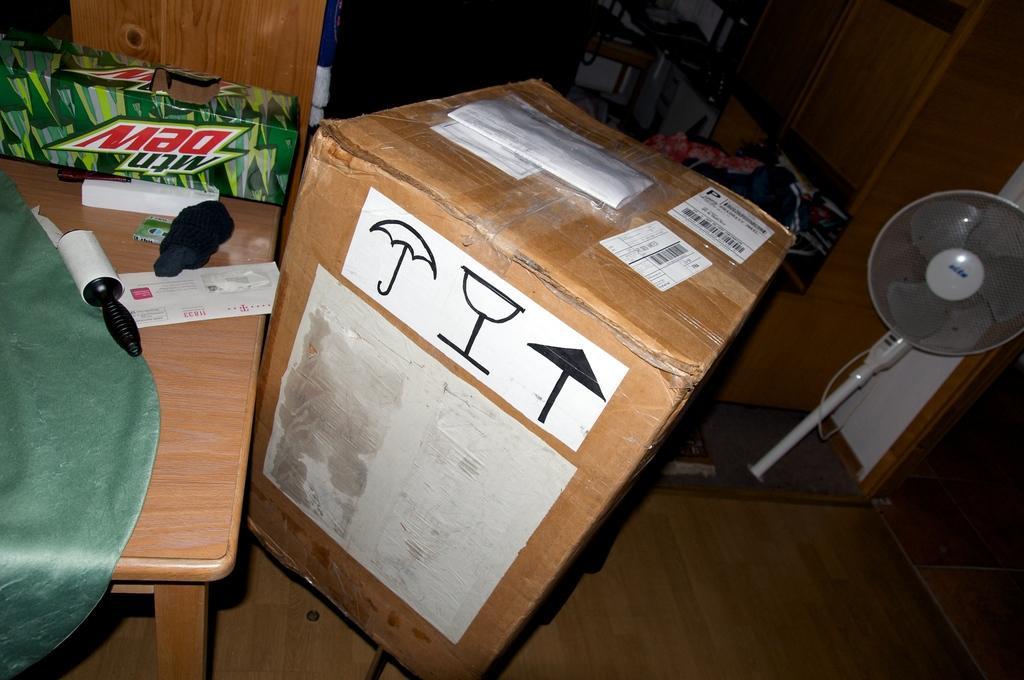Describe this image in one or two sentences. In this picture I can see a table which has some objects on it. Here I can see a box and a table fan. In the background I can see some wooden objects. 